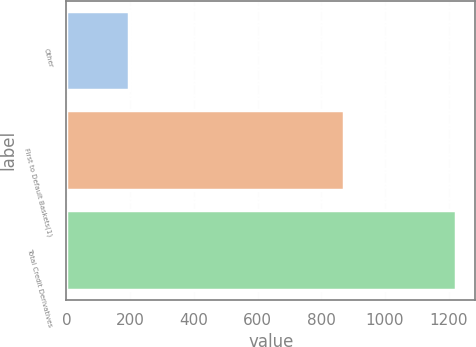Convert chart. <chart><loc_0><loc_0><loc_500><loc_500><bar_chart><fcel>Other<fcel>First to Default Baskets(1)<fcel>Total Credit Derivatives<nl><fcel>195<fcel>872<fcel>1222<nl></chart> 